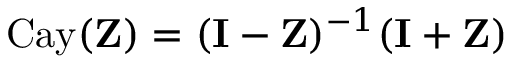Convert formula to latex. <formula><loc_0><loc_0><loc_500><loc_500>C a y ( Z ) = ( I - Z ) ^ { - 1 } ( I + Z )</formula> 